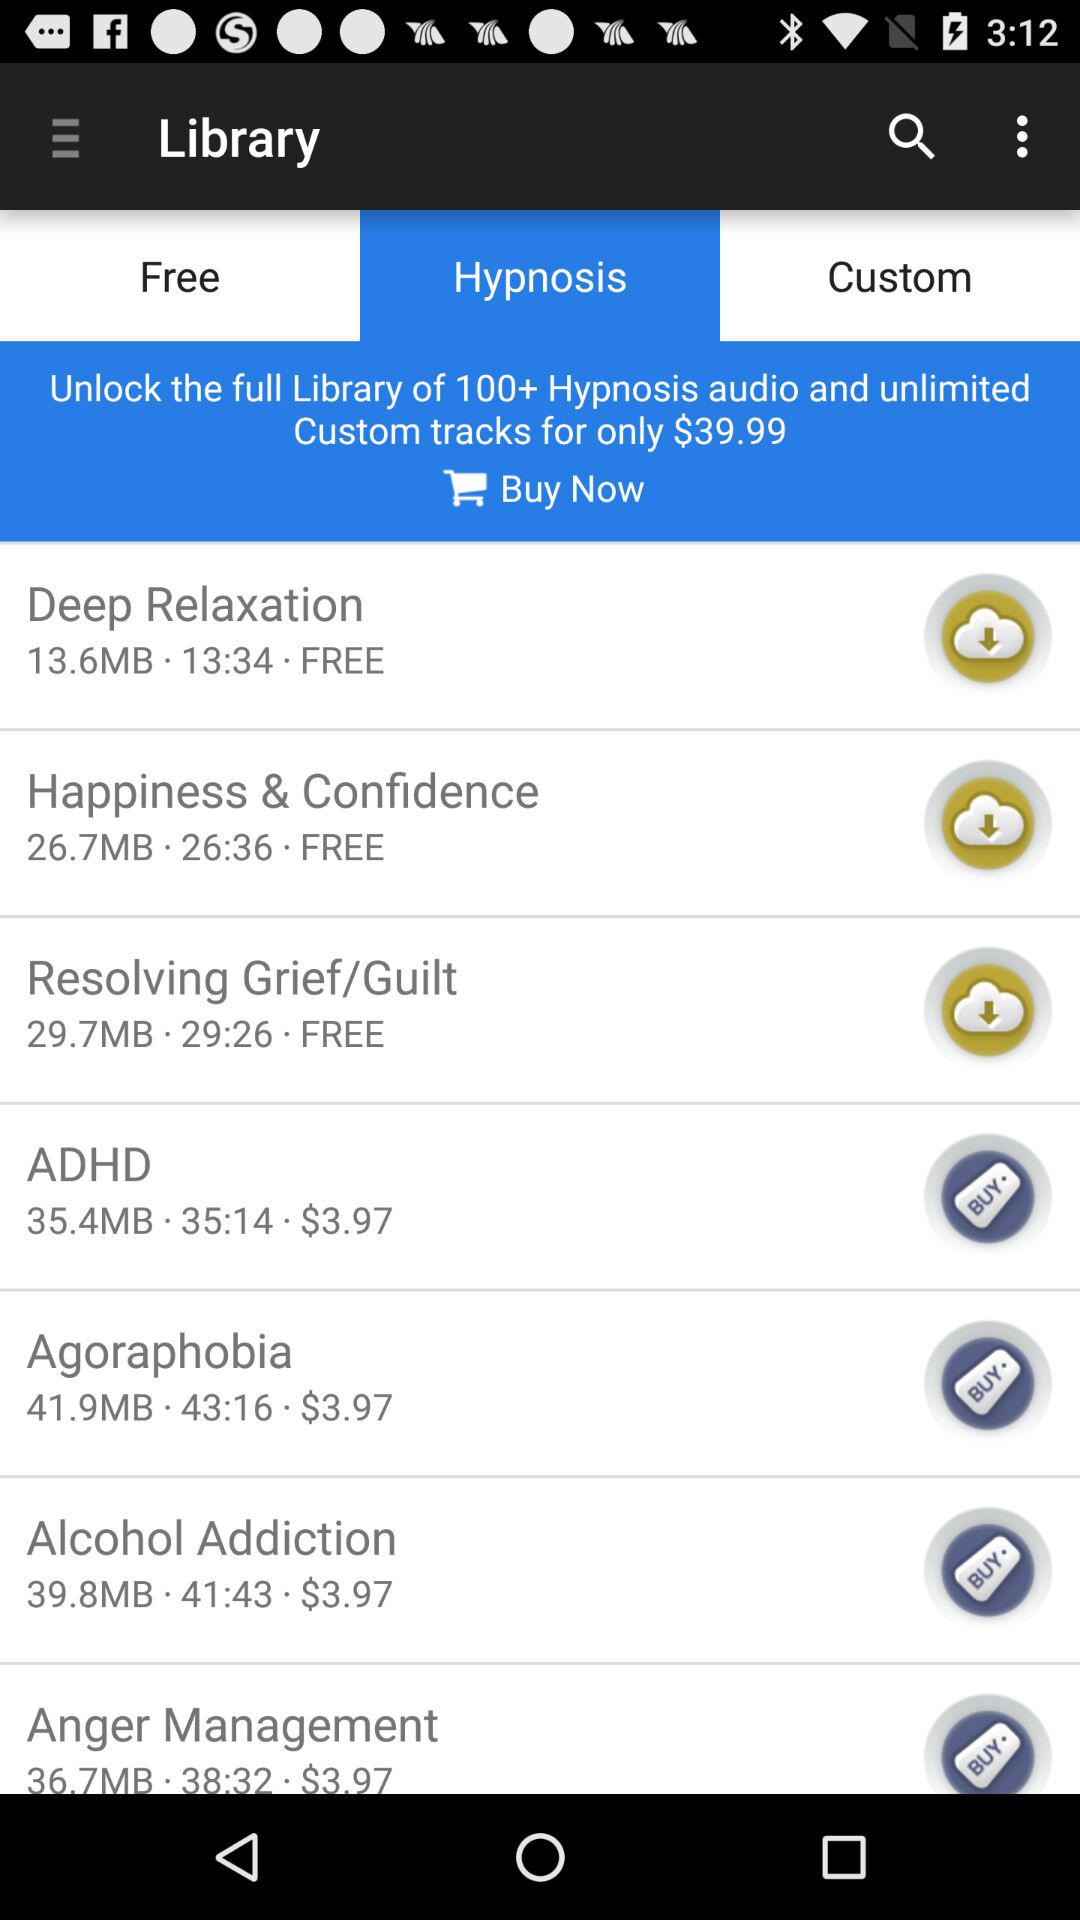What option has been selected for the library? The selected option is "Hypnosis". 